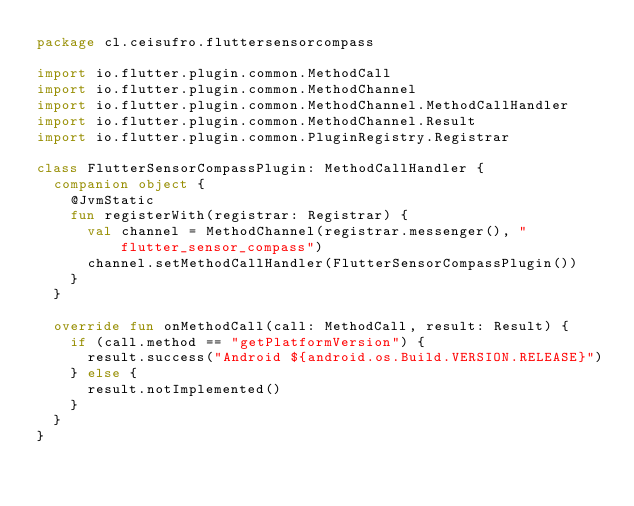Convert code to text. <code><loc_0><loc_0><loc_500><loc_500><_Kotlin_>package cl.ceisufro.fluttersensorcompass

import io.flutter.plugin.common.MethodCall
import io.flutter.plugin.common.MethodChannel
import io.flutter.plugin.common.MethodChannel.MethodCallHandler
import io.flutter.plugin.common.MethodChannel.Result
import io.flutter.plugin.common.PluginRegistry.Registrar

class FlutterSensorCompassPlugin: MethodCallHandler {
  companion object {
    @JvmStatic
    fun registerWith(registrar: Registrar) {
      val channel = MethodChannel(registrar.messenger(), "flutter_sensor_compass")
      channel.setMethodCallHandler(FlutterSensorCompassPlugin())
    }
  }

  override fun onMethodCall(call: MethodCall, result: Result) {
    if (call.method == "getPlatformVersion") {
      result.success("Android ${android.os.Build.VERSION.RELEASE}")
    } else {
      result.notImplemented()
    }
  }
}
</code> 